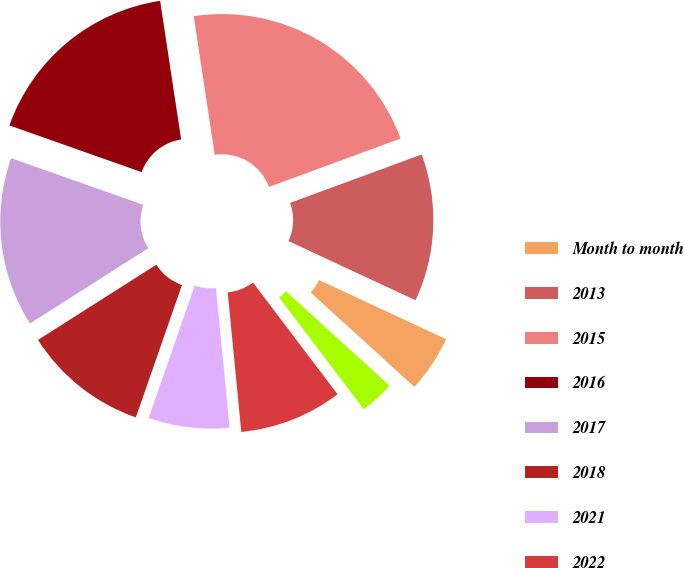Convert chart. <chart><loc_0><loc_0><loc_500><loc_500><pie_chart><fcel>Month to month<fcel>2013<fcel>2015<fcel>2016<fcel>2017<fcel>2018<fcel>2021<fcel>2022<fcel>2014<nl><fcel>4.82%<fcel>12.54%<fcel>21.79%<fcel>17.2%<fcel>14.42%<fcel>10.65%<fcel>6.88%<fcel>8.77%<fcel>2.93%<nl></chart> 